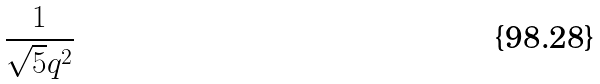Convert formula to latex. <formula><loc_0><loc_0><loc_500><loc_500>\frac { 1 } { \sqrt { 5 } q ^ { 2 } }</formula> 